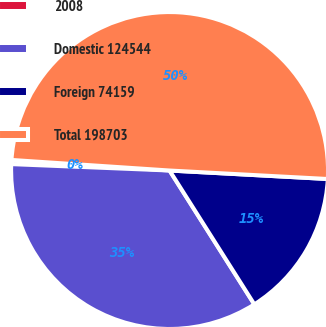Convert chart to OTSL. <chart><loc_0><loc_0><loc_500><loc_500><pie_chart><fcel>2008<fcel>Domestic 124544<fcel>Foreign 74159<fcel>Total 198703<nl><fcel>0.42%<fcel>34.63%<fcel>15.16%<fcel>49.79%<nl></chart> 